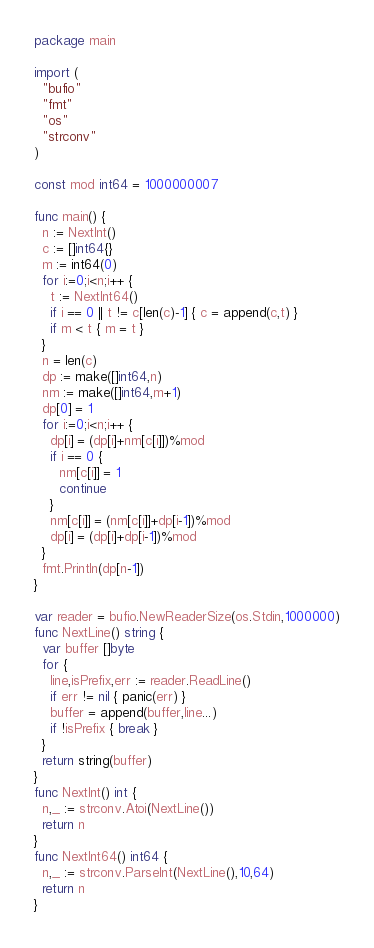Convert code to text. <code><loc_0><loc_0><loc_500><loc_500><_Go_>package main

import (
  "bufio"
  "fmt"
  "os"
  "strconv"
)

const mod int64 = 1000000007

func main() {
  n := NextInt()
  c := []int64{}
  m := int64(0)
  for i:=0;i<n;i++ {
    t := NextInt64()
    if i == 0 || t != c[len(c)-1] { c = append(c,t) }
    if m < t { m = t }
  }
  n = len(c)
  dp := make([]int64,n)
  nm := make([]int64,m+1)
  dp[0] = 1
  for i:=0;i<n;i++ {
    dp[i] = (dp[i]+nm[c[i]])%mod
    if i == 0 {
      nm[c[i]] = 1
      continue
    }
    nm[c[i]] = (nm[c[i]]+dp[i-1])%mod
    dp[i] = (dp[i]+dp[i-1])%mod
  }
  fmt.Println(dp[n-1])
}

var reader = bufio.NewReaderSize(os.Stdin,1000000)
func NextLine() string {
  var buffer []byte
  for {
    line,isPrefix,err := reader.ReadLine()
    if err != nil { panic(err) }
    buffer = append(buffer,line...)
    if !isPrefix { break }
  }
  return string(buffer)
}
func NextInt() int {
  n,_ := strconv.Atoi(NextLine())
  return n
}
func NextInt64() int64 {
  n,_ := strconv.ParseInt(NextLine(),10,64)
  return n
}</code> 